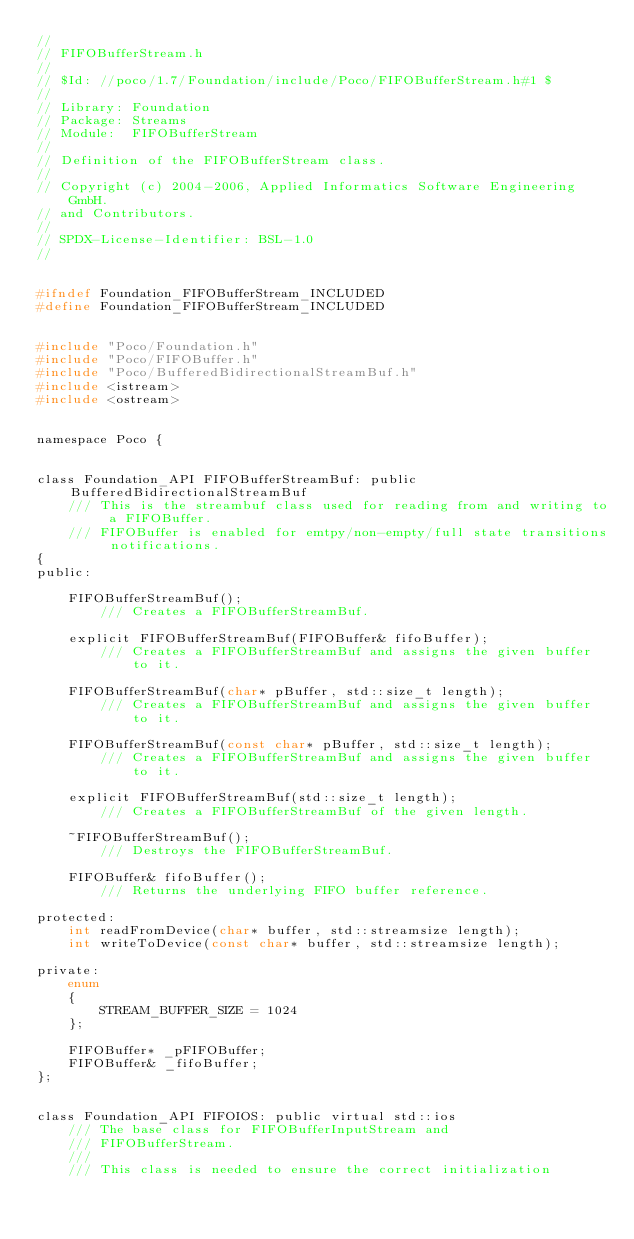Convert code to text. <code><loc_0><loc_0><loc_500><loc_500><_C_>//
// FIFOBufferStream.h
//
// $Id: //poco/1.7/Foundation/include/Poco/FIFOBufferStream.h#1 $
//
// Library: Foundation
// Package: Streams
// Module:  FIFOBufferStream
//
// Definition of the FIFOBufferStream class.
//
// Copyright (c) 2004-2006, Applied Informatics Software Engineering GmbH.
// and Contributors.
//
// SPDX-License-Identifier:	BSL-1.0
//


#ifndef Foundation_FIFOBufferStream_INCLUDED
#define Foundation_FIFOBufferStream_INCLUDED


#include "Poco/Foundation.h"
#include "Poco/FIFOBuffer.h"
#include "Poco/BufferedBidirectionalStreamBuf.h"
#include <istream>
#include <ostream>


namespace Poco {


class Foundation_API FIFOBufferStreamBuf: public BufferedBidirectionalStreamBuf
	/// This is the streambuf class used for reading from and writing to a FIFOBuffer.
	/// FIFOBuffer is enabled for emtpy/non-empty/full state transitions notifications.
{
public:
	
	FIFOBufferStreamBuf();
		/// Creates a FIFOBufferStreamBuf.

	explicit FIFOBufferStreamBuf(FIFOBuffer& fifoBuffer);
		/// Creates a FIFOBufferStreamBuf and assigns the given buffer to it.

	FIFOBufferStreamBuf(char* pBuffer, std::size_t length);
		/// Creates a FIFOBufferStreamBuf and assigns the given buffer to it.

	FIFOBufferStreamBuf(const char* pBuffer, std::size_t length);
		/// Creates a FIFOBufferStreamBuf and assigns the given buffer to it.

	explicit FIFOBufferStreamBuf(std::size_t length);
		/// Creates a FIFOBufferStreamBuf of the given length.

	~FIFOBufferStreamBuf();
		/// Destroys the FIFOBufferStreamBuf.

	FIFOBuffer& fifoBuffer();
		/// Returns the underlying FIFO buffer reference.

protected:
	int readFromDevice(char* buffer, std::streamsize length);
	int writeToDevice(const char* buffer, std::streamsize length);

private:
	enum 
	{
		STREAM_BUFFER_SIZE = 1024
	};

	FIFOBuffer* _pFIFOBuffer;
	FIFOBuffer& _fifoBuffer;
};


class Foundation_API FIFOIOS: public virtual std::ios
	/// The base class for FIFOBufferInputStream and
	/// FIFOBufferStream.
	///
	/// This class is needed to ensure the correct initialization</code> 